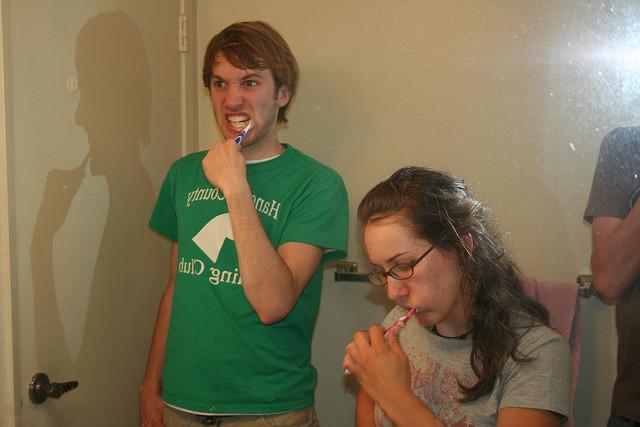<image>Where is the boy? The exact location of the boy is unknown. He could be on the left side, in the bathroom, or near the door. What game are these men playing? I don't know what game the men are playing. It seems like they could be brushing their teeth. Where do you see a tattoo? There is no visible tattoo in the image. What is this front woman's favorite team? It is not possible to determine the front woman's favorite team from the information given. Does the woman color her hair? It is unknown if the woman colors her hair. Where is the boy? I don't know where the boy is. He can be on the left side, in the bathroom, or next to the girl. What game are these men playing? I don't know what game these men are playing. It can be seen that they are either playing soccer or brushing their teeth. Where do you see a tattoo? There is no tattoo seen in the image. It is nowhere to be found. What is this front woman's favorite team? I don't know what is this front woman's favorite team. It is not possible to determine from the information given. Does the woman color her hair? I don't know if the woman colors her hair. It is possible that she does not color her hair. 